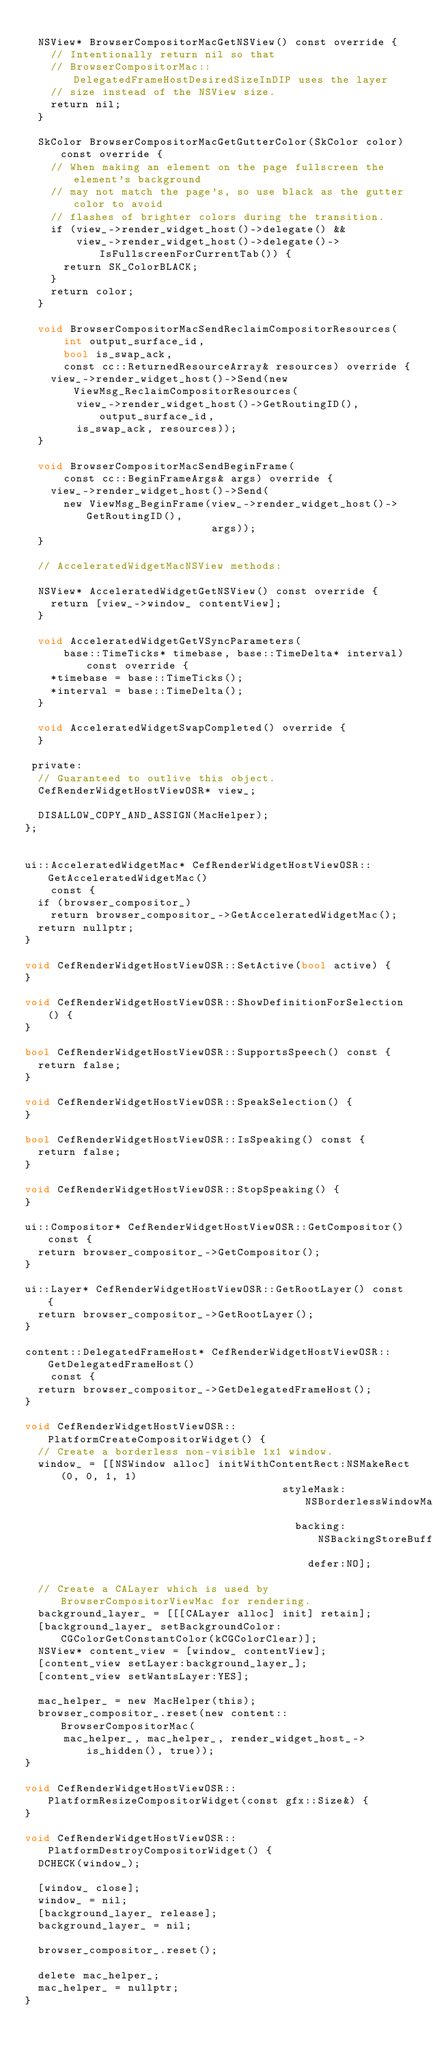Convert code to text. <code><loc_0><loc_0><loc_500><loc_500><_ObjectiveC_>
  NSView* BrowserCompositorMacGetNSView() const override {
    // Intentionally return nil so that
    // BrowserCompositorMac::DelegatedFrameHostDesiredSizeInDIP uses the layer
    // size instead of the NSView size.
    return nil;
  }

  SkColor BrowserCompositorMacGetGutterColor(SkColor color) const override {
    // When making an element on the page fullscreen the element's background
    // may not match the page's, so use black as the gutter color to avoid
    // flashes of brighter colors during the transition.
    if (view_->render_widget_host()->delegate() &&
        view_->render_widget_host()->delegate()->IsFullscreenForCurrentTab()) {
      return SK_ColorBLACK;
    }
    return color;
  }

  void BrowserCompositorMacSendReclaimCompositorResources(
      int output_surface_id,
      bool is_swap_ack,
      const cc::ReturnedResourceArray& resources) override {
    view_->render_widget_host()->Send(new ViewMsg_ReclaimCompositorResources(
        view_->render_widget_host()->GetRoutingID(), output_surface_id,
        is_swap_ack, resources));
  }

  void BrowserCompositorMacSendBeginFrame(
      const cc::BeginFrameArgs& args) override {
    view_->render_widget_host()->Send(
      new ViewMsg_BeginFrame(view_->render_widget_host()->GetRoutingID(),
                             args));
  }

  // AcceleratedWidgetMacNSView methods:

  NSView* AcceleratedWidgetGetNSView() const override {
    return [view_->window_ contentView];
  }

  void AcceleratedWidgetGetVSyncParameters(
      base::TimeTicks* timebase, base::TimeDelta* interval) const override {
    *timebase = base::TimeTicks();
    *interval = base::TimeDelta();
  }

  void AcceleratedWidgetSwapCompleted() override {
  }

 private:
  // Guaranteed to outlive this object.
  CefRenderWidgetHostViewOSR* view_;

  DISALLOW_COPY_AND_ASSIGN(MacHelper);
};


ui::AcceleratedWidgetMac* CefRenderWidgetHostViewOSR::GetAcceleratedWidgetMac()
    const {
  if (browser_compositor_)
    return browser_compositor_->GetAcceleratedWidgetMac();
  return nullptr;
}

void CefRenderWidgetHostViewOSR::SetActive(bool active) {
}

void CefRenderWidgetHostViewOSR::ShowDefinitionForSelection() {
}

bool CefRenderWidgetHostViewOSR::SupportsSpeech() const {
  return false;
}

void CefRenderWidgetHostViewOSR::SpeakSelection() {
}

bool CefRenderWidgetHostViewOSR::IsSpeaking() const {
  return false;
}

void CefRenderWidgetHostViewOSR::StopSpeaking() {
}

ui::Compositor* CefRenderWidgetHostViewOSR::GetCompositor() const {
  return browser_compositor_->GetCompositor();
}

ui::Layer* CefRenderWidgetHostViewOSR::GetRootLayer() const {
  return browser_compositor_->GetRootLayer();
}

content::DelegatedFrameHost* CefRenderWidgetHostViewOSR::GetDelegatedFrameHost()
    const {
  return browser_compositor_->GetDelegatedFrameHost();
}

void CefRenderWidgetHostViewOSR::PlatformCreateCompositorWidget() {
  // Create a borderless non-visible 1x1 window.
  window_ = [[NSWindow alloc] initWithContentRect:NSMakeRect(0, 0, 1, 1)
                                        styleMask:NSBorderlessWindowMask
                                          backing:NSBackingStoreBuffered
                                            defer:NO];

  // Create a CALayer which is used by BrowserCompositorViewMac for rendering.
  background_layer_ = [[[CALayer alloc] init] retain];
  [background_layer_ setBackgroundColor:CGColorGetConstantColor(kCGColorClear)];
  NSView* content_view = [window_ contentView];
  [content_view setLayer:background_layer_];
  [content_view setWantsLayer:YES];

  mac_helper_ = new MacHelper(this);
  browser_compositor_.reset(new content::BrowserCompositorMac(
      mac_helper_, mac_helper_, render_widget_host_->is_hidden(), true));
}

void CefRenderWidgetHostViewOSR::PlatformResizeCompositorWidget(const gfx::Size&) {
}

void CefRenderWidgetHostViewOSR::PlatformDestroyCompositorWidget() {
  DCHECK(window_);

  [window_ close];
  window_ = nil;
  [background_layer_ release];
  background_layer_ = nil;

  browser_compositor_.reset();

  delete mac_helper_;
  mac_helper_ = nullptr;
}
</code> 